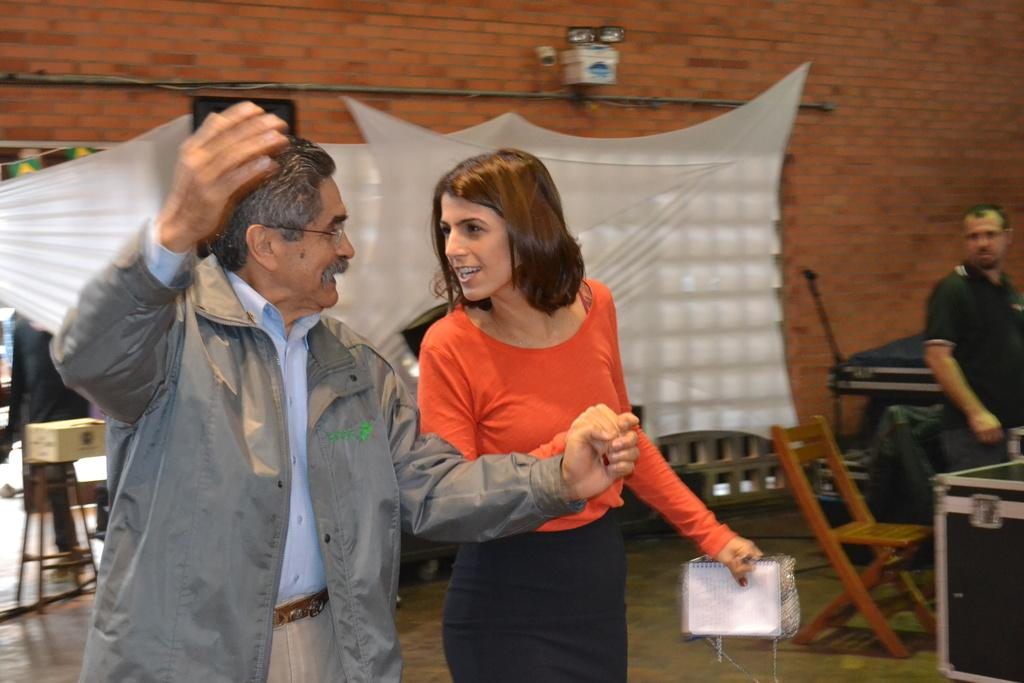How many people are in the image? There are 2 people in the image. What are the two people doing? The two people are holding hands and looking at each other. Can you describe the background of the image? In the background, there is a person, white curtains, chairs, tables, and a brick wall with lights. What type of sea creature can be seen in the image? There is no sea creature present in the image. How does the person in the background react to the shocking news? There is no indication of any shocking news or reaction in the image. 